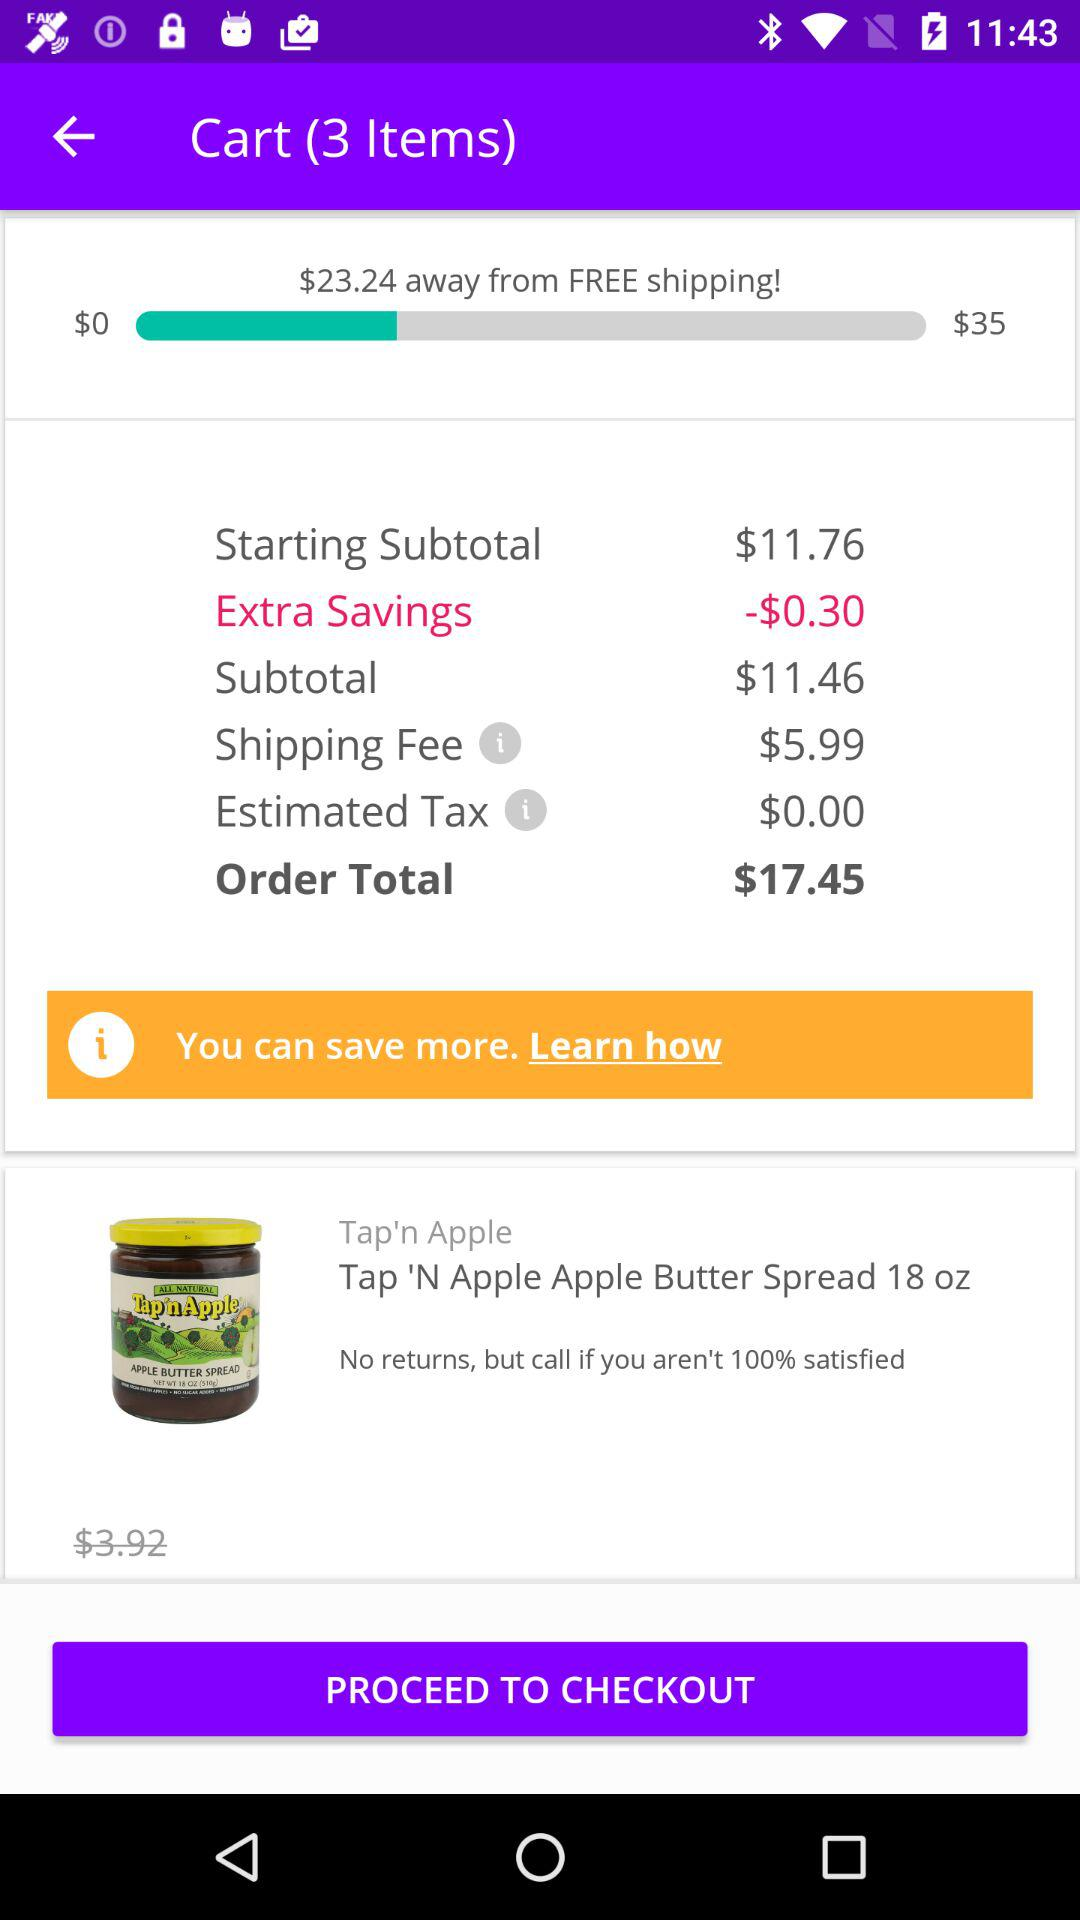How much amount is remaining to get free shipping? The remaining amount is $23.24. 